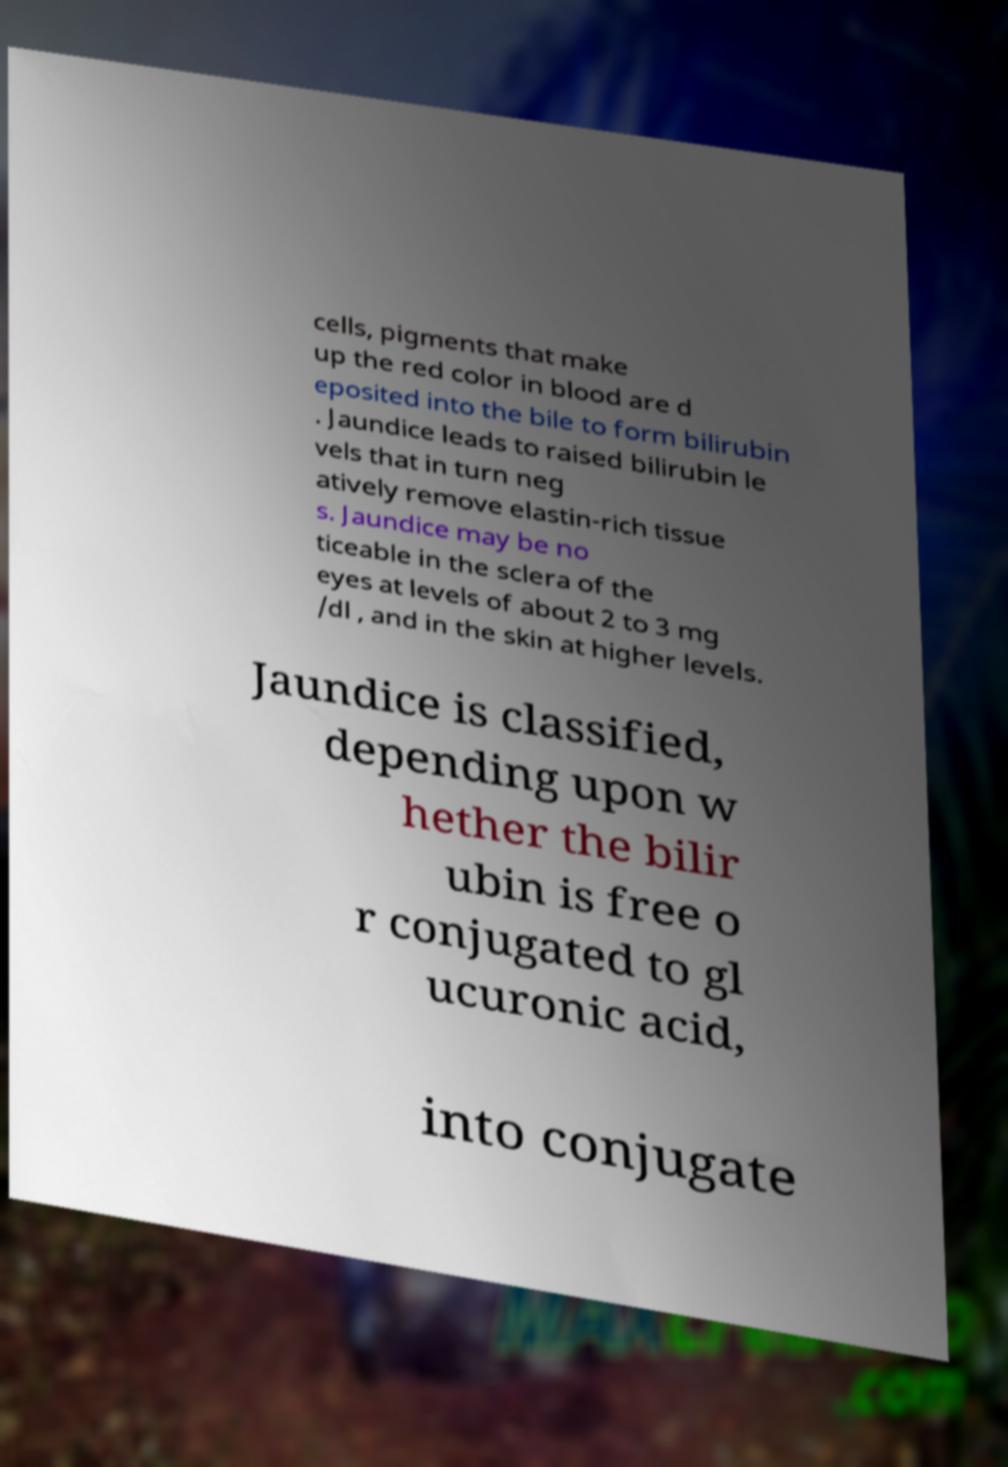I need the written content from this picture converted into text. Can you do that? cells, pigments that make up the red color in blood are d eposited into the bile to form bilirubin . Jaundice leads to raised bilirubin le vels that in turn neg atively remove elastin-rich tissue s. Jaundice may be no ticeable in the sclera of the eyes at levels of about 2 to 3 mg /dl , and in the skin at higher levels. Jaundice is classified, depending upon w hether the bilir ubin is free o r conjugated to gl ucuronic acid, into conjugate 